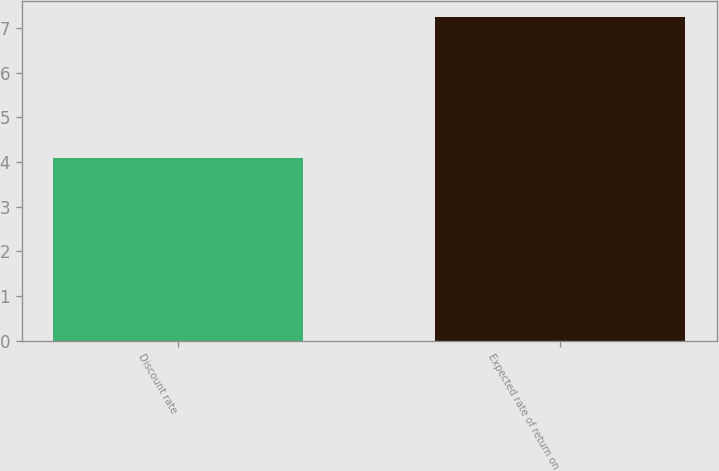Convert chart to OTSL. <chart><loc_0><loc_0><loc_500><loc_500><bar_chart><fcel>Discount rate<fcel>Expected rate of return on<nl><fcel>4.1<fcel>7.25<nl></chart> 